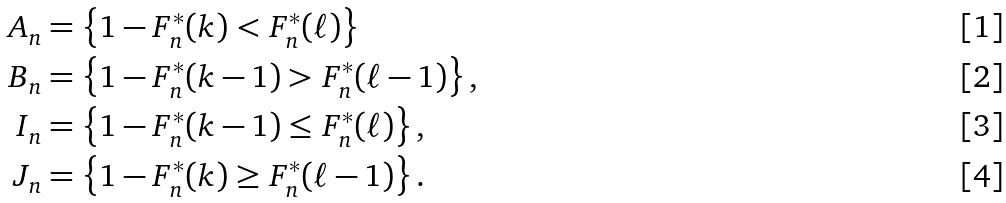Convert formula to latex. <formula><loc_0><loc_0><loc_500><loc_500>A _ { n } & = \left \{ 1 - F _ { n } ^ { \ast } ( k ) < F _ { n } ^ { \ast } ( \ell ) \right \} \\ B _ { n } & = \left \{ 1 - F _ { n } ^ { \ast } ( k - 1 ) > F _ { n } ^ { \ast } ( \ell - 1 ) \right \} , \\ I _ { n } & = \left \{ 1 - F _ { n } ^ { \ast } ( k - 1 ) \leq F _ { n } ^ { \ast } ( \ell ) \right \} , \\ J _ { n } & = \left \{ 1 - F _ { n } ^ { \ast } ( k ) \geq F _ { n } ^ { \ast } ( \ell - 1 ) \right \} .</formula> 